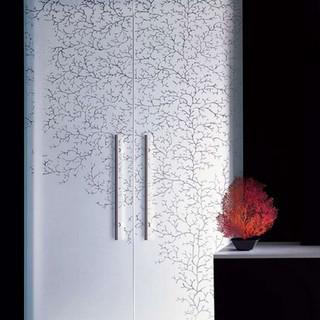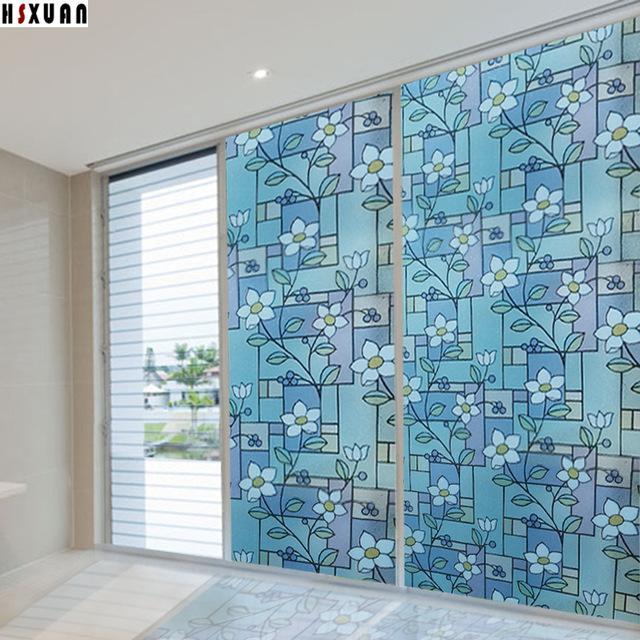The first image is the image on the left, the second image is the image on the right. Evaluate the accuracy of this statement regarding the images: "An image shows a black framed sliding door unit with a narrower middle mirrored section, behind a plush rug and a potted plant.". Is it true? Answer yes or no. No. The first image is the image on the left, the second image is the image on the right. For the images displayed, is the sentence "Both images contain an object with a plant design on it." factually correct? Answer yes or no. Yes. 